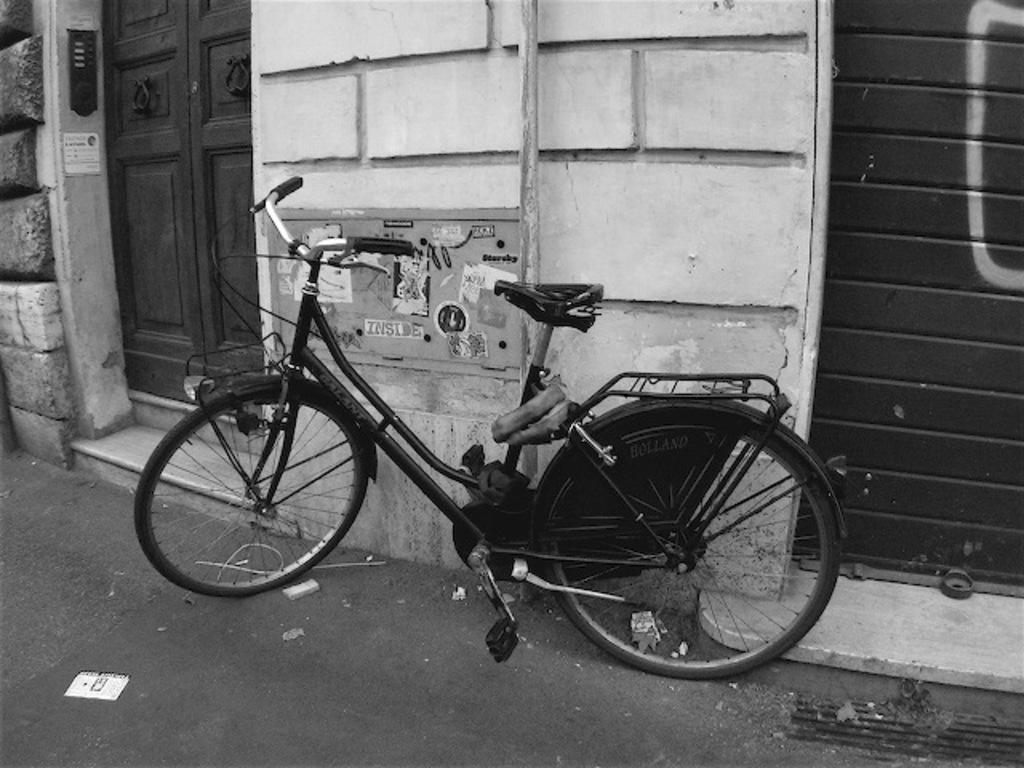Can you describe this image briefly? In this image I can see a bicycle in the front. On the left side of this image I can see doors and on the right side I can see a shutter. I can also see number of papers on the wall and I can see this image is black and white in colour. 